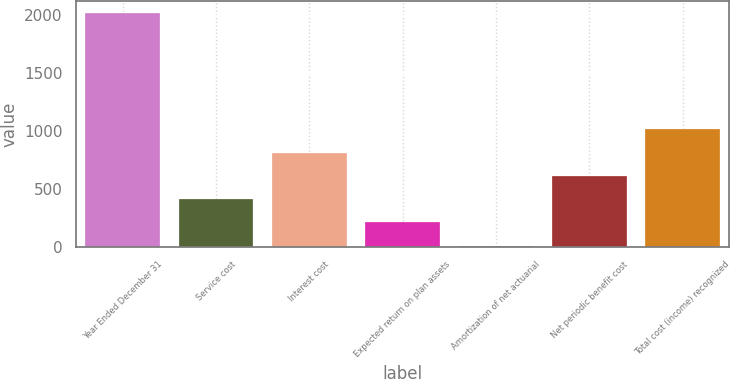Convert chart. <chart><loc_0><loc_0><loc_500><loc_500><bar_chart><fcel>Year Ended December 31<fcel>Service cost<fcel>Interest cost<fcel>Expected return on plan assets<fcel>Amortization of net actuarial<fcel>Net periodic benefit cost<fcel>Total cost (income) recognized<nl><fcel>2016<fcel>408.8<fcel>810.6<fcel>207.9<fcel>7<fcel>609.7<fcel>1011.5<nl></chart> 